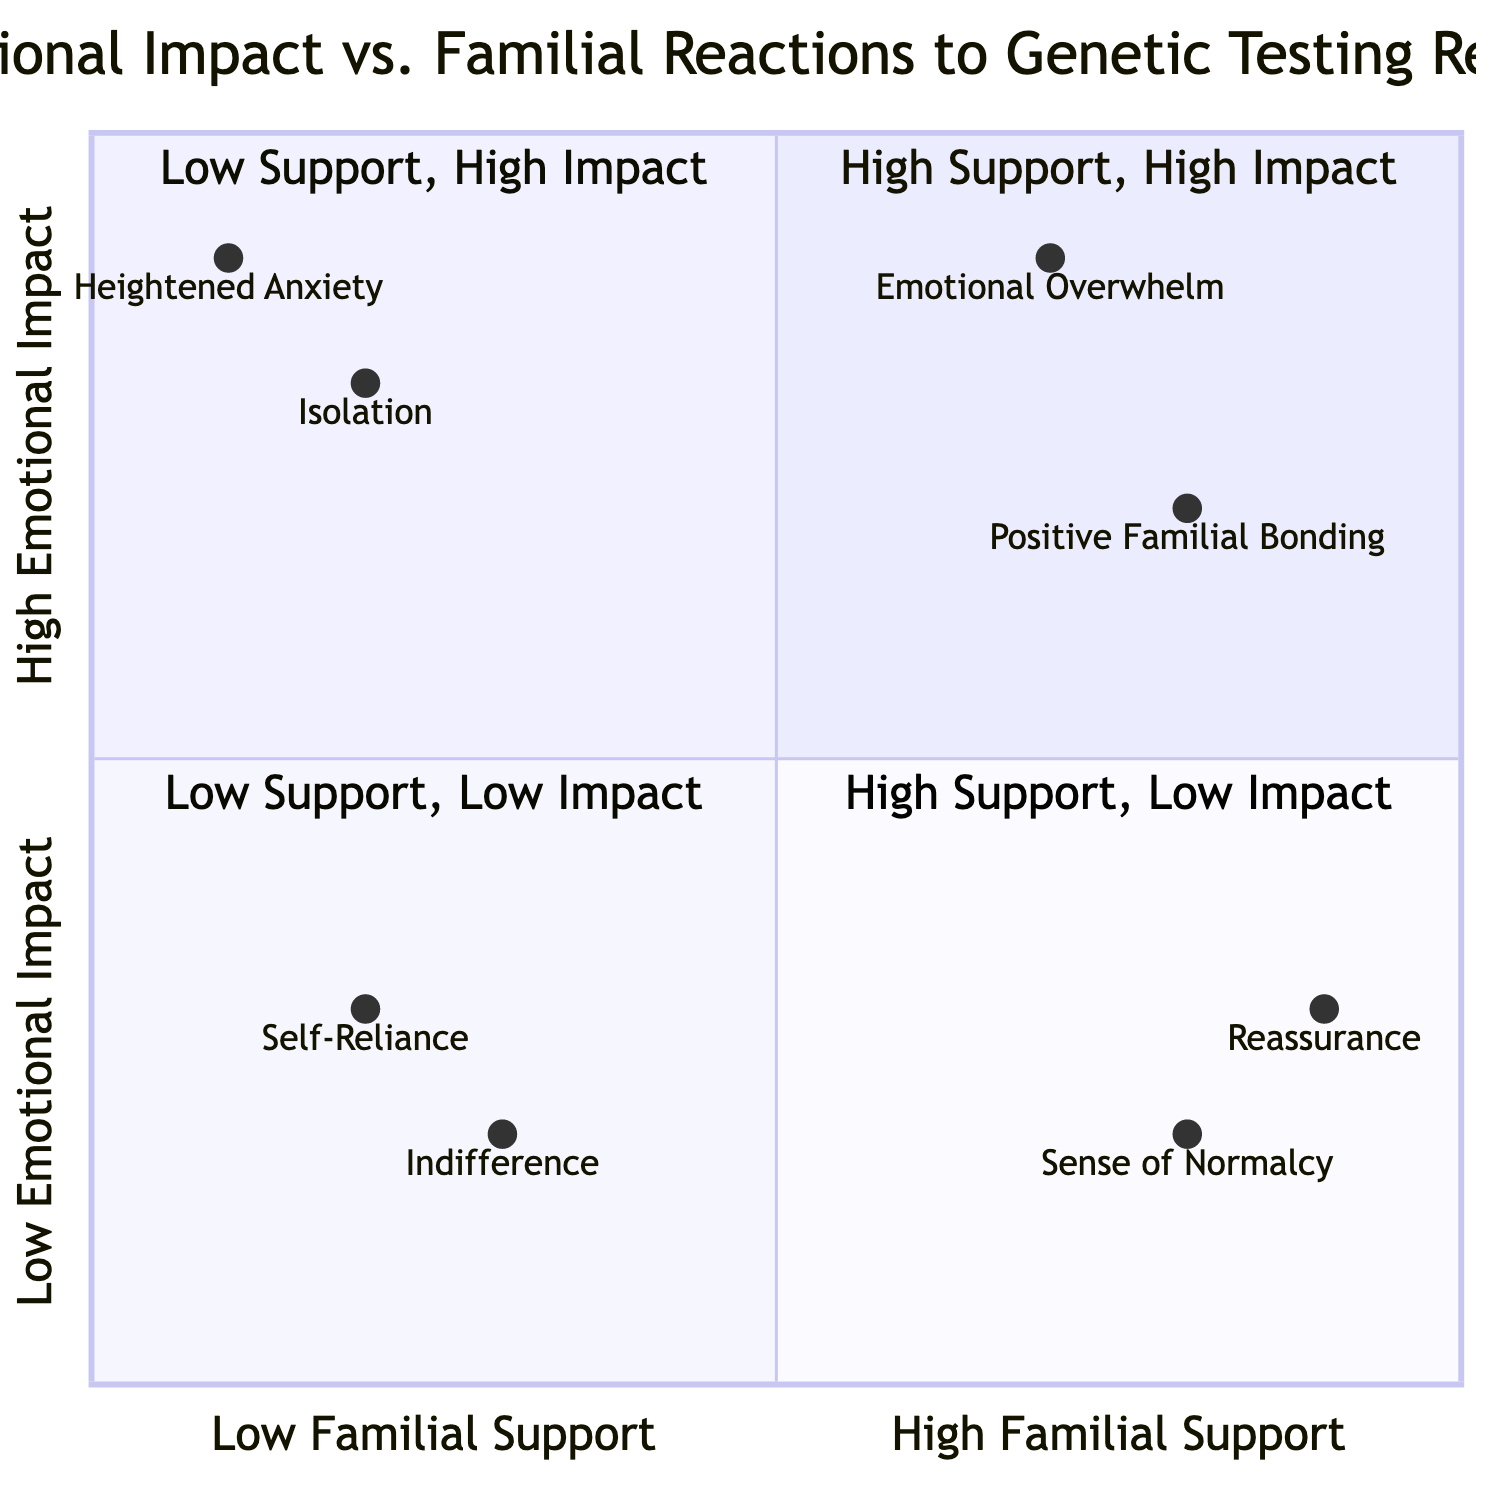What is the highest point in the Emotional Impact axis? The highest point on the Emotional Impact axis is represented by Emotional Overwhelm at 0.9. The diagram shows this value clearly along the Y-axis.
Answer: 0.9 Which quadrant contains the element "Isolation"? The element "Isolation" is found in the Low Familial Support and High Emotional Impact quadrant. By examining the placement of nodes, Isolation corresponds to Y and X coordinates that fall into this specific quadrant.
Answer: Low Support, High Impact How many elements are in the High Support, High Impact quadrant? The High Support, High Impact quadrant contains two elements: Positive Familial Bonding and Emotional Overwhelm. This is determined by counting the elements listed in that quadrant within the diagram.
Answer: 2 What is the emotional impact of "Reassurance"? The emotional impact of "Reassurance" is 0.3 as indicated by its Y-coordinate in the quadrant chart. This value is specifically noted next to the element in the High Support, Low Impact quadrant.
Answer: 0.3 What does the Low Support, Low Impact quadrant represent? The Low Support, Low Impact quadrant represents cases of Indifference and Self-Reliance. This is determined by identifying the specific elements listed in that quadrant and the characteristics associated with it.
Answer: Indifference and Self-Reliance Which element has the highest familial support score? The element with the highest familial support score is Reassurance at 0.9. The familial support values are displayed along the X-axis, and this particular element has the highest figure indicating strong familial backing.
Answer: 0.9 What is the emotional impact for the element "Heightened Anxiety"? The emotional impact for the element "Heightened Anxiety" is 0.9. This is seen directly beside the element within its respective quadrant, which is clearly labeled on the chart.
Answer: 0.9 How does "Self-Reliance" score on the Emotional Impact axis compared to "Emotional Overwhelm"? "Self-Reliance" scores 0.3, while "Emotional Overwhelm" scores 0.9, indicating that Emotional Overwhelm has a significantly higher emotional impact than Self-Reliance. This comparison is made by evaluating the Y-values of both elements in the diagram.
Answer: Emotional Overwhelm is higher In which quadrant do we find the element "Sense of Normalcy"? The element "Sense of Normalcy" is found in the High Support, Low Impact quadrant. This is identified by its placement in the diagram according to its familial support and emotional impact scores.
Answer: High Support, Low Impact 